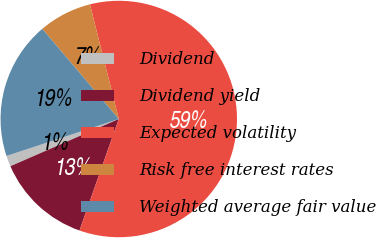<chart> <loc_0><loc_0><loc_500><loc_500><pie_chart><fcel>Dividend<fcel>Dividend yield<fcel>Expected volatility<fcel>Risk free interest rates<fcel>Weighted average fair value<nl><fcel>1.48%<fcel>13.07%<fcel>59.31%<fcel>7.28%<fcel>18.86%<nl></chart> 